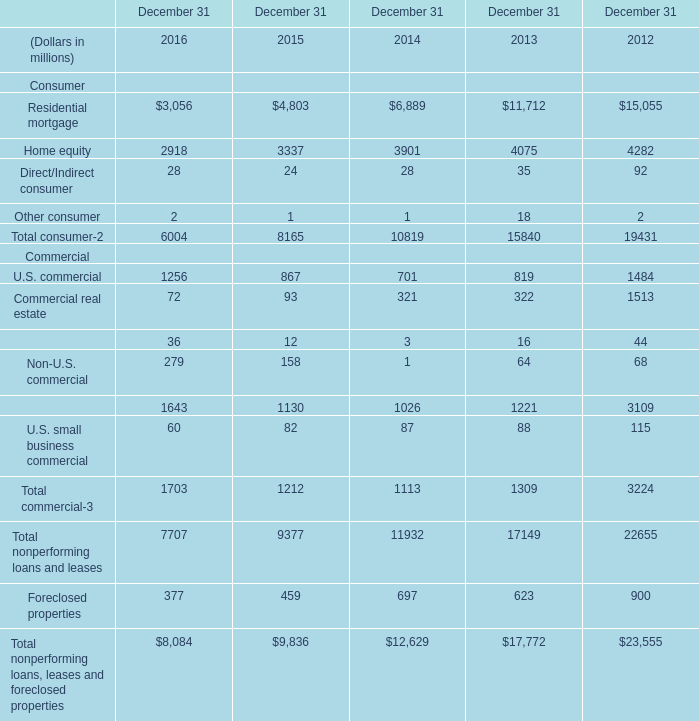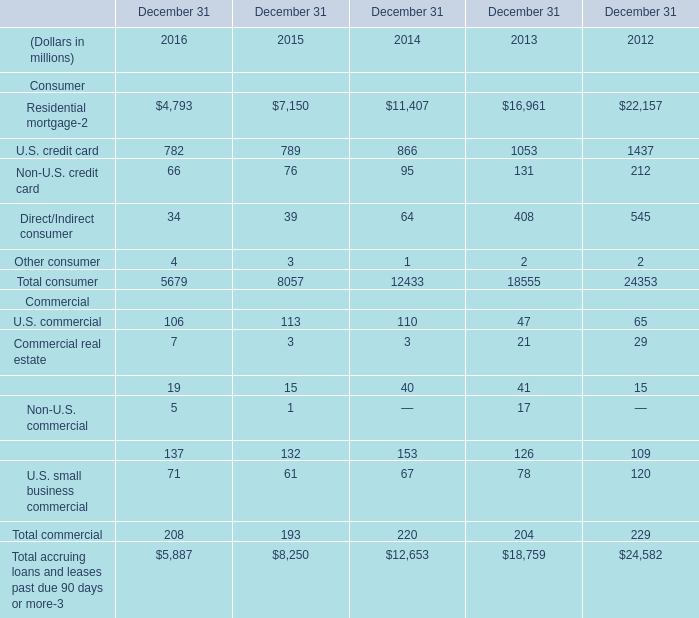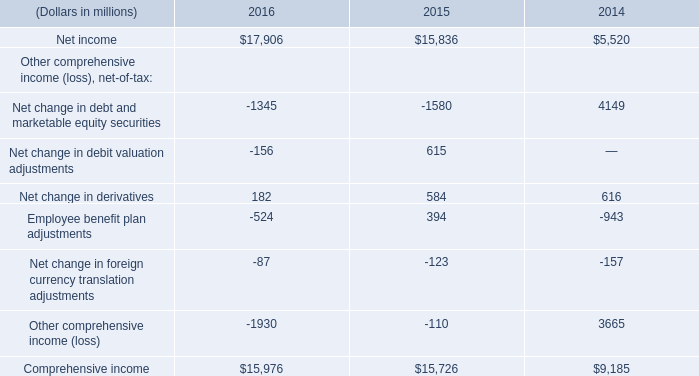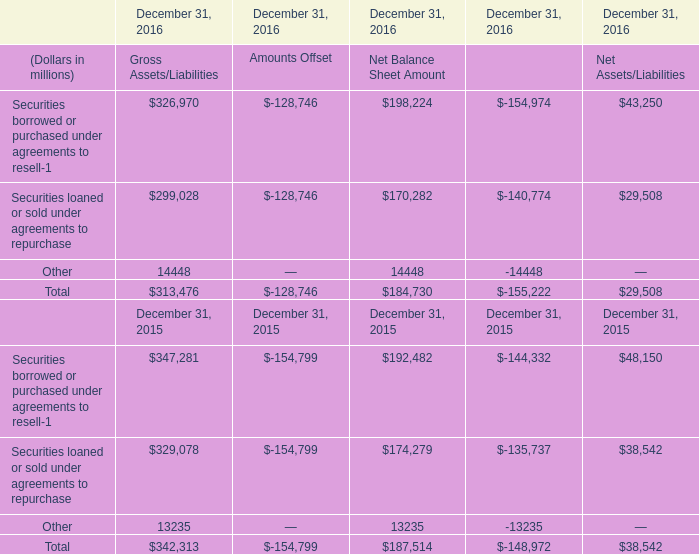What is the total amount of Residential mortgage of December 31 2014, and Other of December 31, 2016 Net Balance Sheet Amount ? 
Computations: (6889.0 + 14448.0)
Answer: 21337.0. 